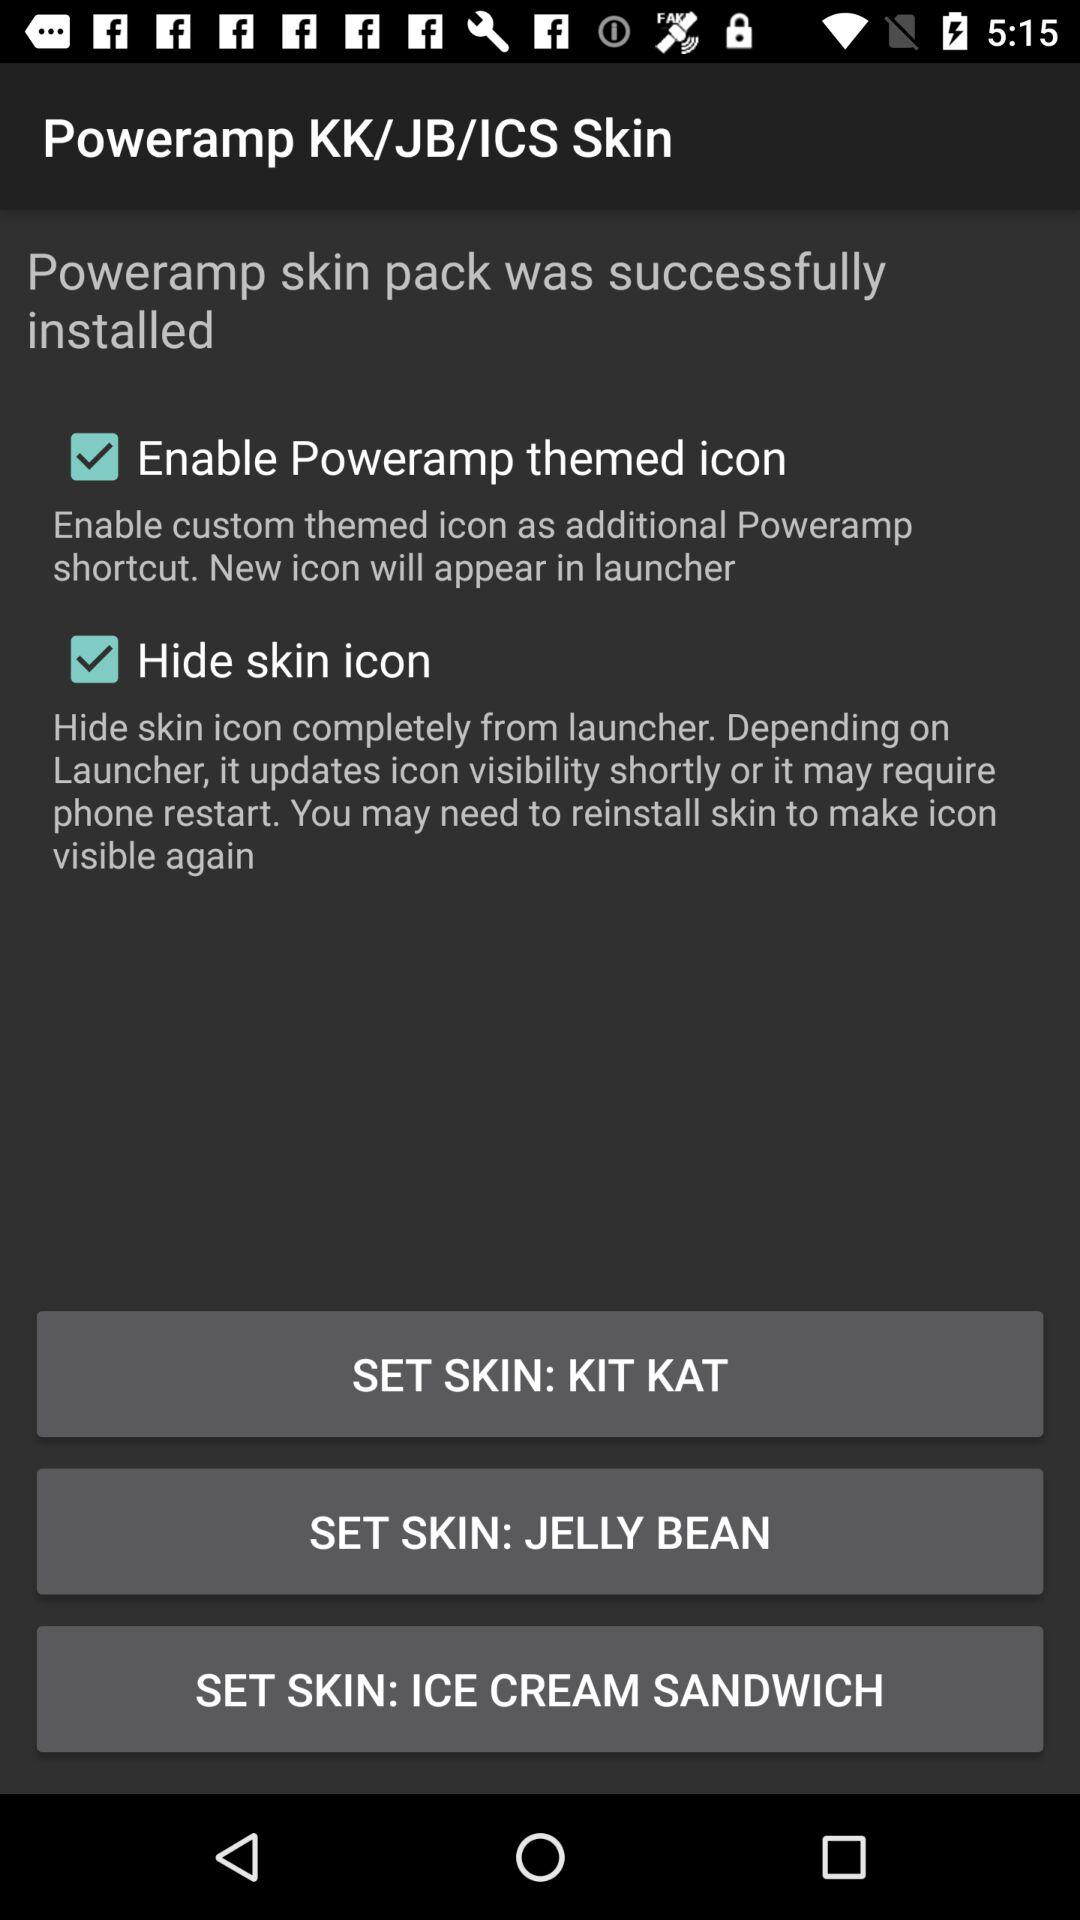How many options are available to choose from for the skin?
Answer the question using a single word or phrase. 3 